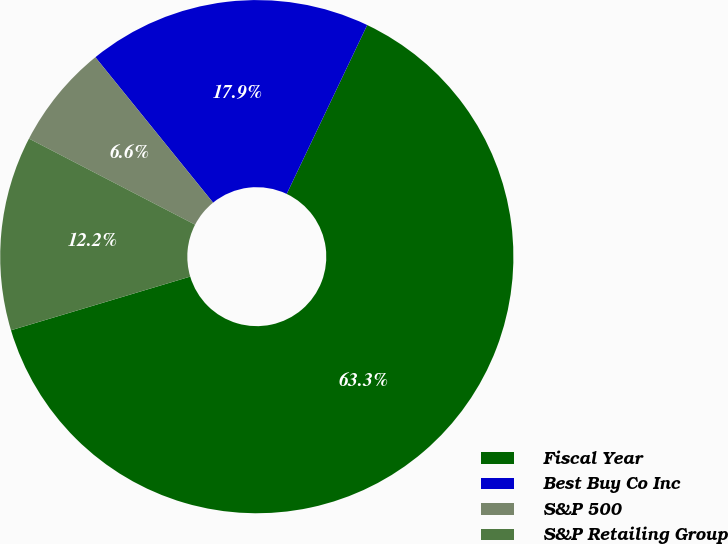Convert chart to OTSL. <chart><loc_0><loc_0><loc_500><loc_500><pie_chart><fcel>Fiscal Year<fcel>Best Buy Co Inc<fcel>S&P 500<fcel>S&P Retailing Group<nl><fcel>63.29%<fcel>17.91%<fcel>6.56%<fcel>12.24%<nl></chart> 